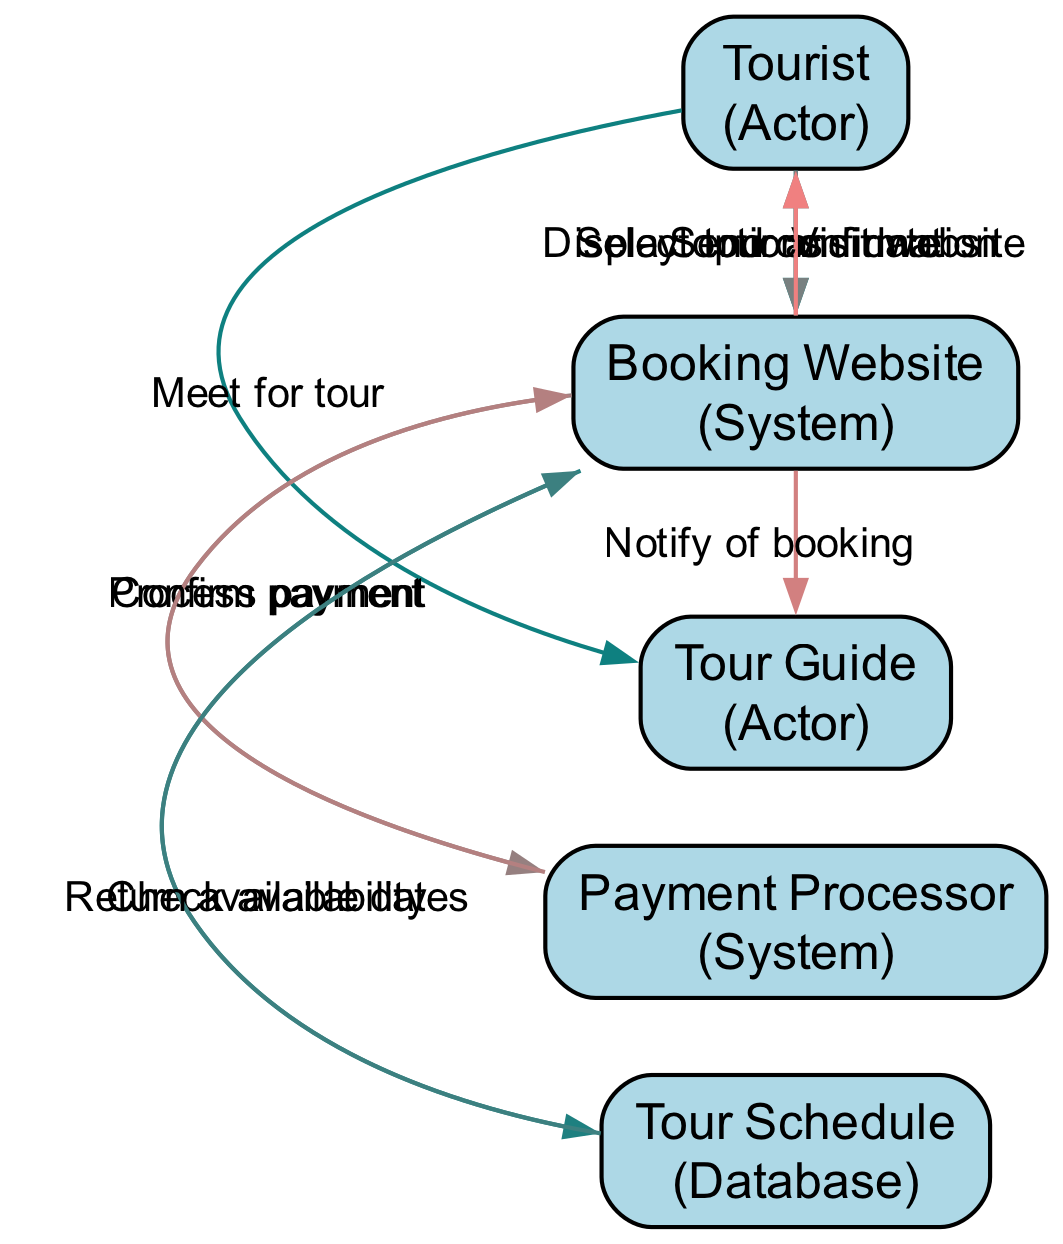What are the main actors in the sequence diagram? The main actors in the diagram are the Tourist and the Tour Guide. They represent the visitors and the person conducting the tour, respectively.
Answer: Tourist, Tour Guide How many systems are involved in the booking process? The systems involved are the Booking Website and the Payment Processor. These handle the booking and transaction processes, respectively.
Answer: Two What follows after the tourist selects a tour and date? After the tourist selects a tour and date, the next step is for the Booking Website to process payment by connecting to the Payment Processor.
Answer: Process payment Who receives the confirmation email? The confirmation email is sent to the Tourist, confirming the details of their booking.
Answer: Tourist What is checked after the tourist visits the Booking Website? After the tourist visits the Booking Website, the system checks availability by querying the Tour Schedule database.
Answer: Check availability How many actions are there between the Booking Website and the Payment Processor? There are two actions: the Booking Website processes payment and receives confirmation from the Payment Processor.
Answer: Two Which entity notifies the Tour Guide of the booking? The Booking Website is responsible for notifying the Tour Guide of the booking made by the tourist.
Answer: Booking Website What is the final action in the sequence diagram? The final action in the diagram is the Tourist meeting the Tour Guide for the tour.
Answer: Meet for tour What type of relationship exists between the Tourist and Booking Website? The relationship is a one-way interaction where the Tourist visits the Booking Website to initiate the booking process.
Answer: One-way interaction 